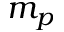<formula> <loc_0><loc_0><loc_500><loc_500>m _ { p }</formula> 